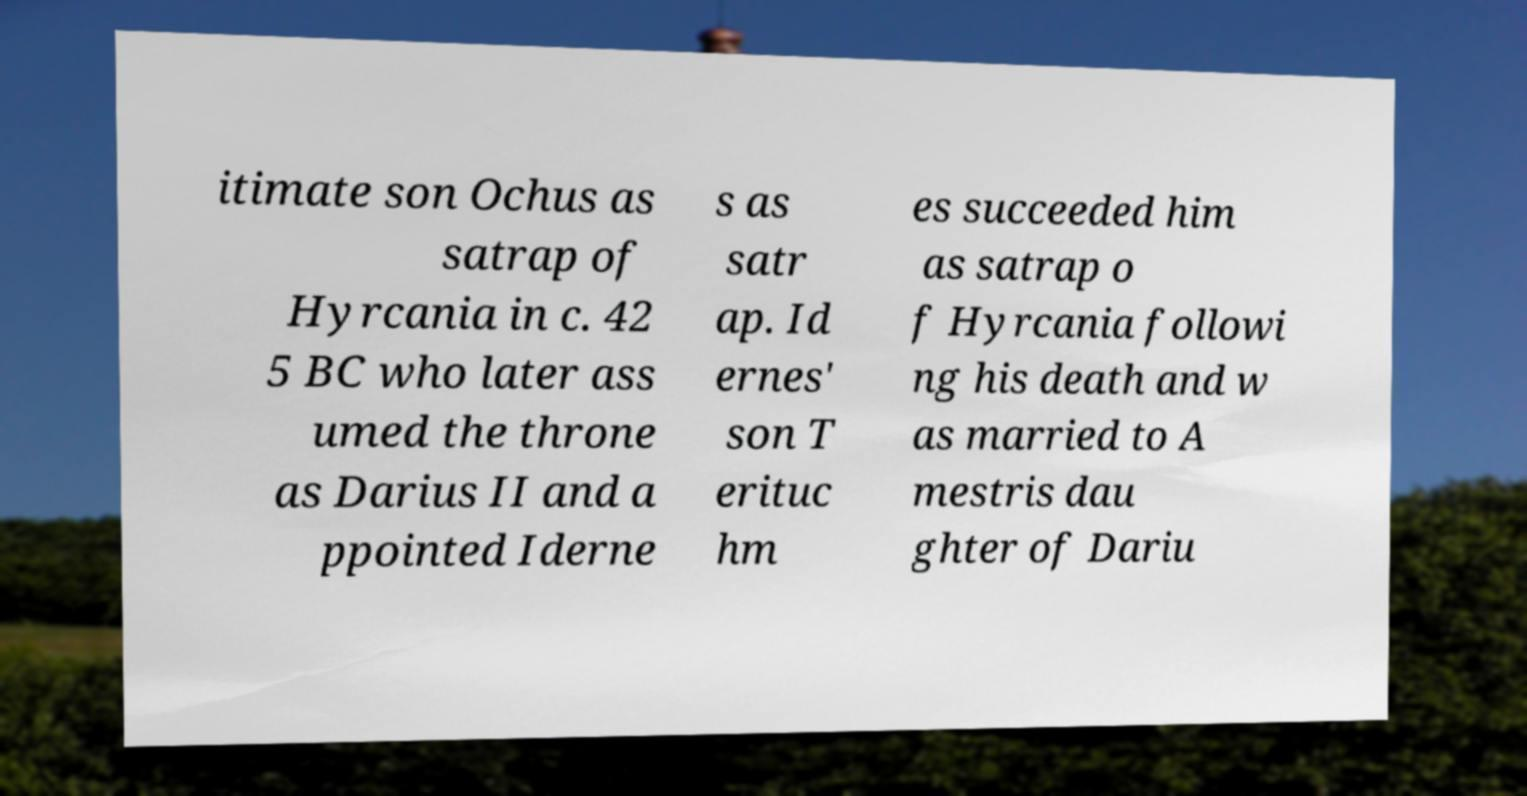Please read and relay the text visible in this image. What does it say? itimate son Ochus as satrap of Hyrcania in c. 42 5 BC who later ass umed the throne as Darius II and a ppointed Iderne s as satr ap. Id ernes' son T erituc hm es succeeded him as satrap o f Hyrcania followi ng his death and w as married to A mestris dau ghter of Dariu 